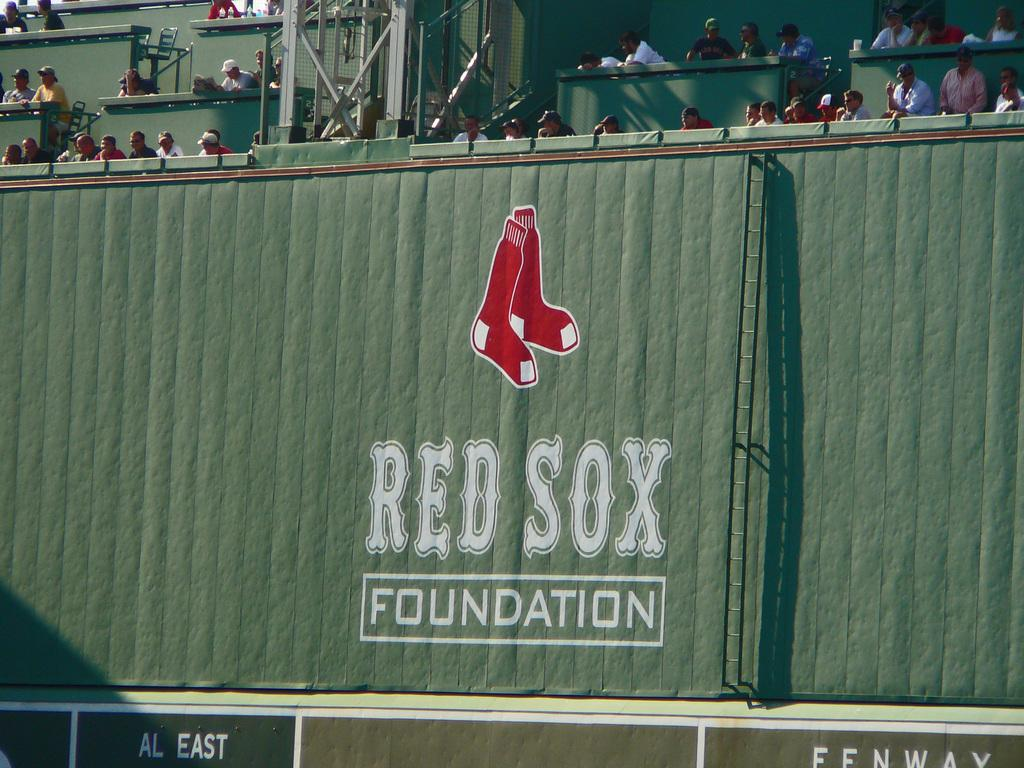What is the main object in the image? The image contains an advertising board. What is the color of the advertising board? The advertising board is green in color. Are there any people visible in the image? Yes, there are people at the top of the advertising board. What type of cake is being served at the bottom of the advertising board? There is no cake present in the image; it features an advertising board with people at the top. Can you see any squirrels interacting with the advertising board? There are no squirrels visible in the image. 